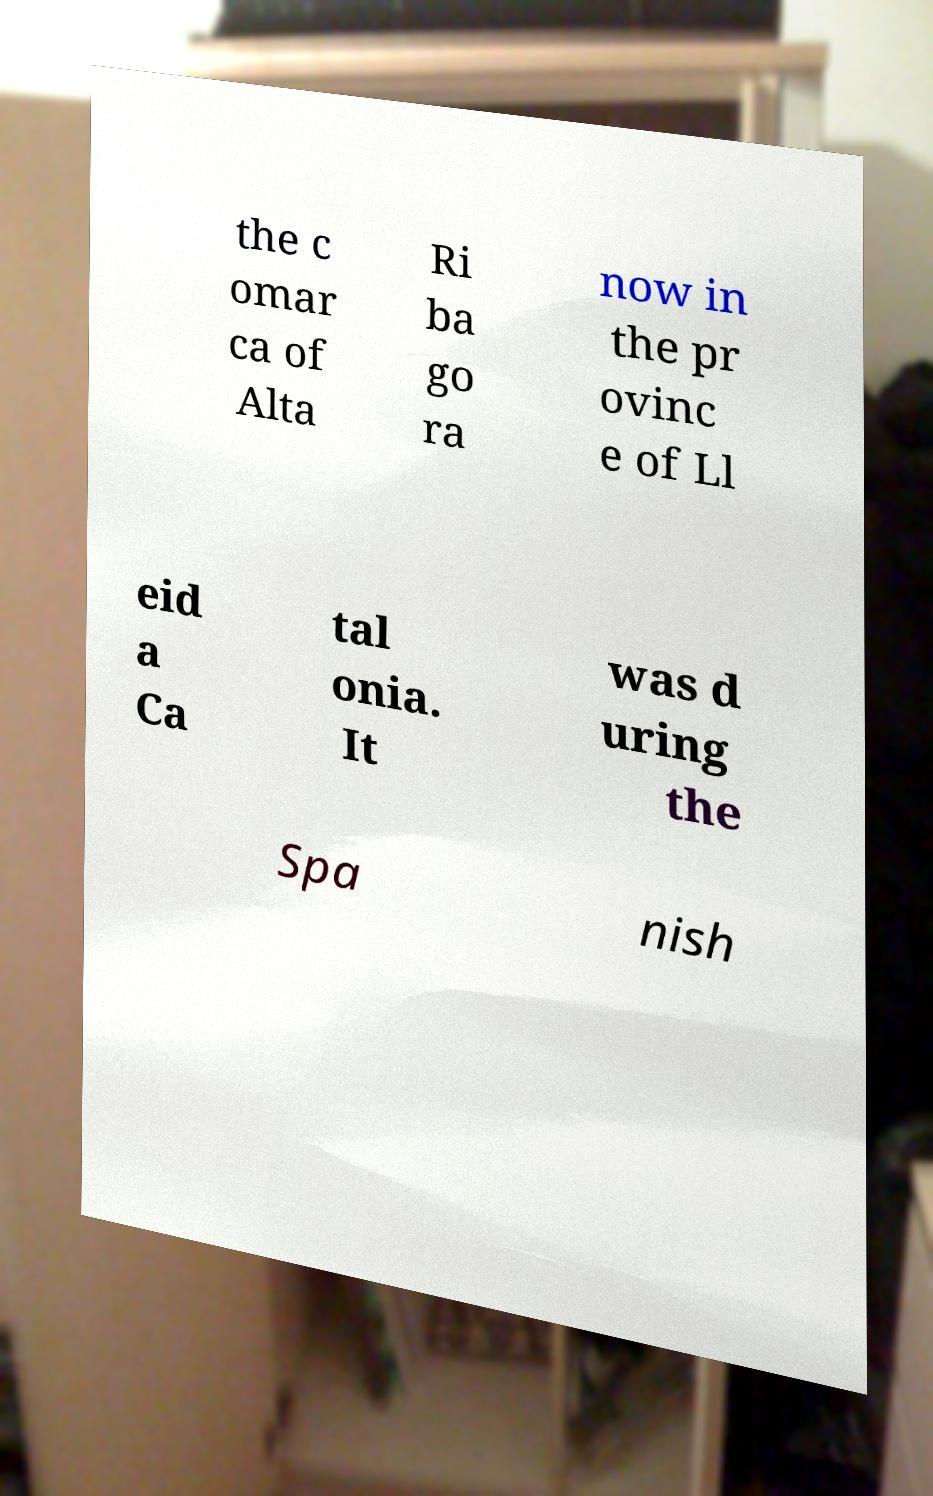What messages or text are displayed in this image? I need them in a readable, typed format. the c omar ca of Alta Ri ba go ra now in the pr ovinc e of Ll eid a Ca tal onia. It was d uring the Spa nish 